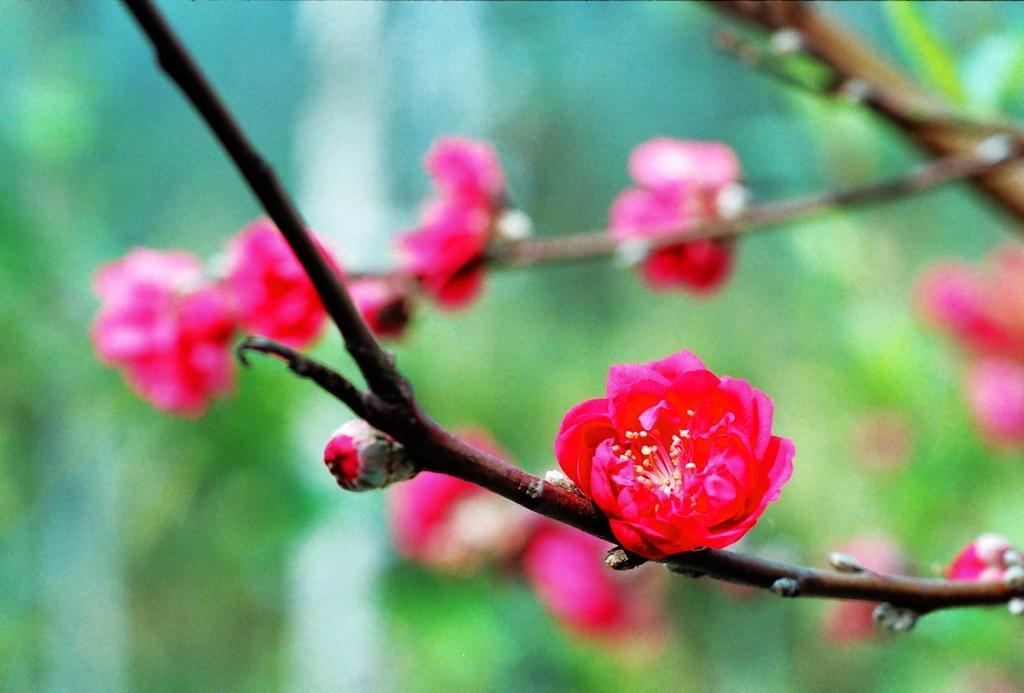In one or two sentences, can you explain what this image depicts? In this image, there are some pink color flowers and there is blur background. 